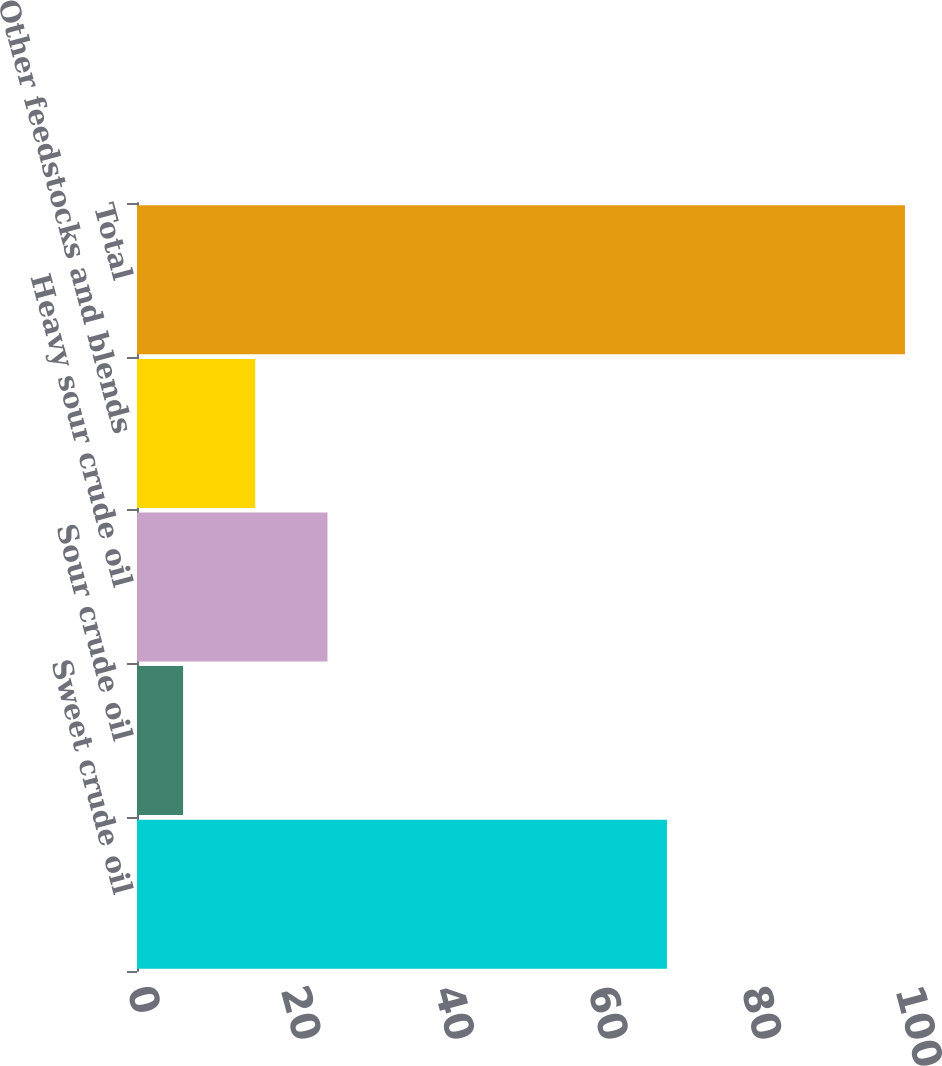Convert chart. <chart><loc_0><loc_0><loc_500><loc_500><bar_chart><fcel>Sweet crude oil<fcel>Sour crude oil<fcel>Heavy sour crude oil<fcel>Other feedstocks and blends<fcel>Total<nl><fcel>69<fcel>6<fcel>24.8<fcel>15.4<fcel>100<nl></chart> 